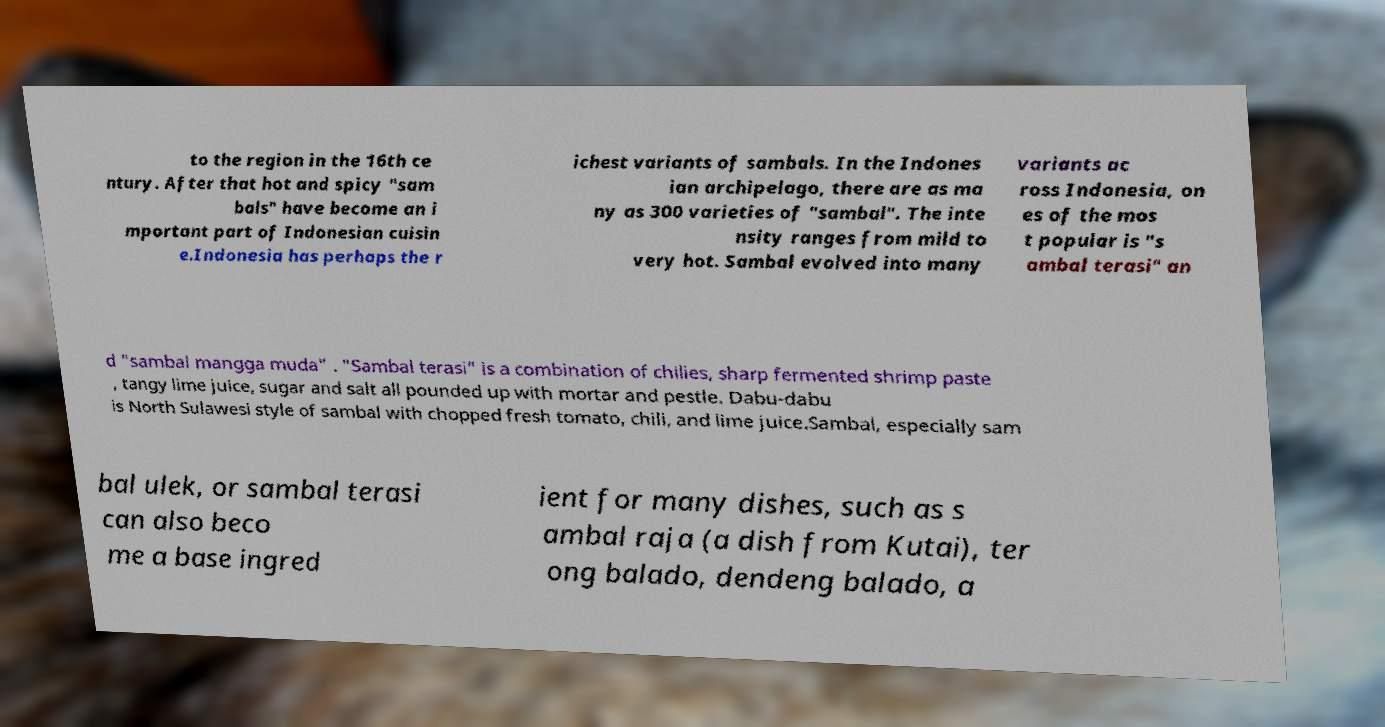Can you accurately transcribe the text from the provided image for me? to the region in the 16th ce ntury. After that hot and spicy "sam bals" have become an i mportant part of Indonesian cuisin e.Indonesia has perhaps the r ichest variants of sambals. In the Indones ian archipelago, there are as ma ny as 300 varieties of "sambal". The inte nsity ranges from mild to very hot. Sambal evolved into many variants ac ross Indonesia, on es of the mos t popular is "s ambal terasi" an d "sambal mangga muda" . "Sambal terasi" is a combination of chilies, sharp fermented shrimp paste , tangy lime juice, sugar and salt all pounded up with mortar and pestle. Dabu-dabu is North Sulawesi style of sambal with chopped fresh tomato, chili, and lime juice.Sambal, especially sam bal ulek, or sambal terasi can also beco me a base ingred ient for many dishes, such as s ambal raja (a dish from Kutai), ter ong balado, dendeng balado, a 